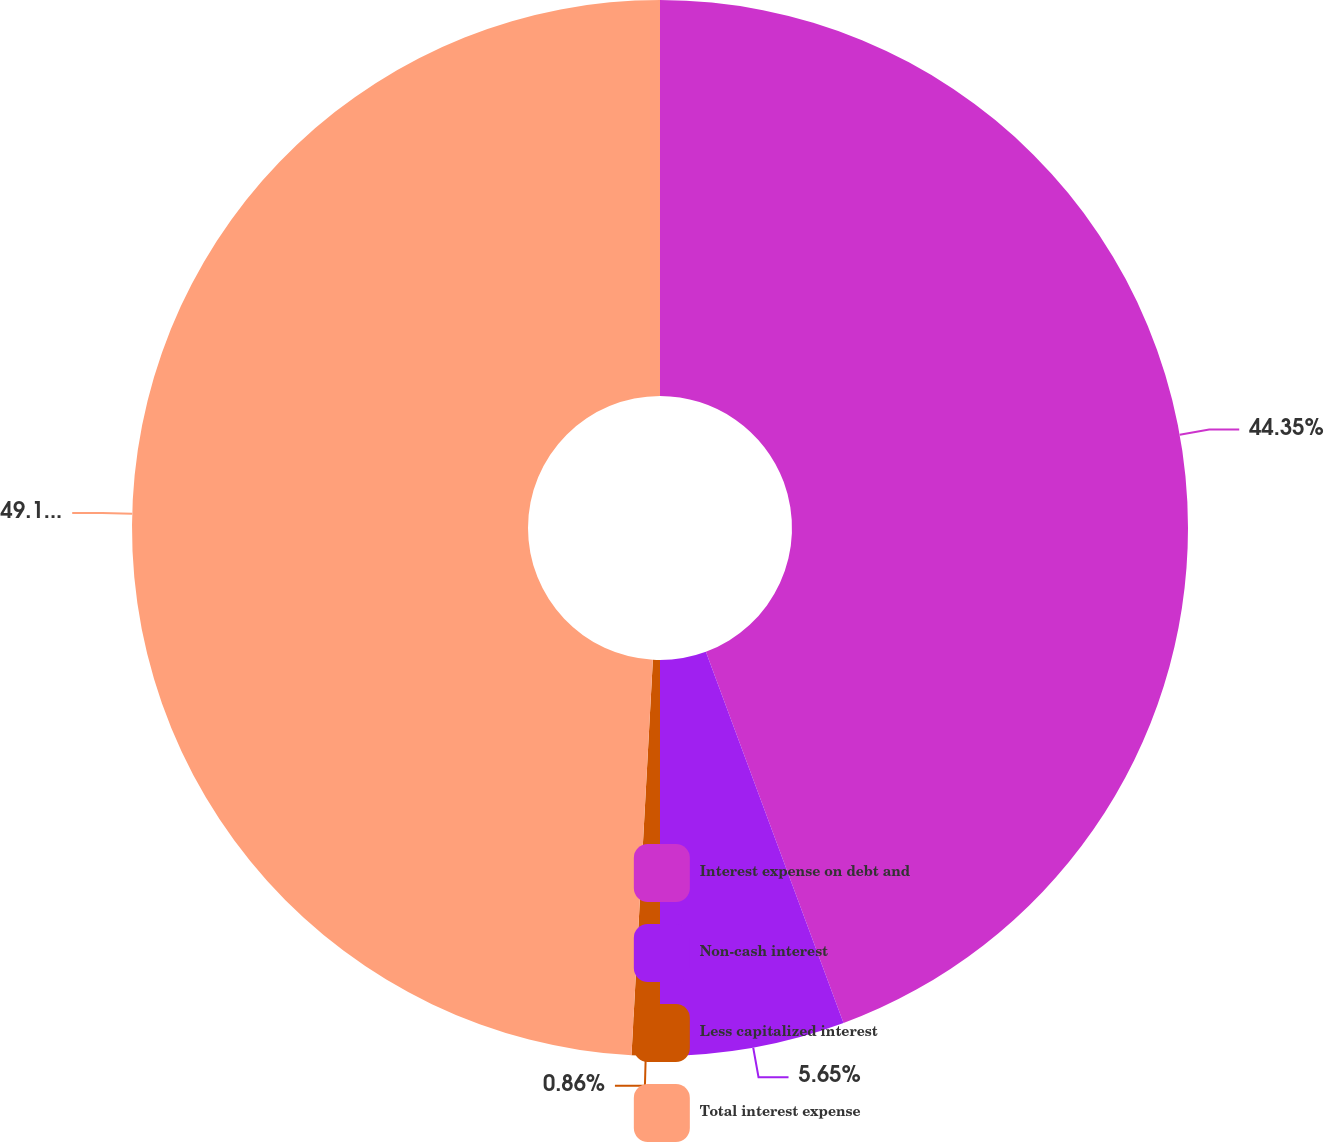<chart> <loc_0><loc_0><loc_500><loc_500><pie_chart><fcel>Interest expense on debt and<fcel>Non-cash interest<fcel>Less capitalized interest<fcel>Total interest expense<nl><fcel>44.35%<fcel>5.65%<fcel>0.86%<fcel>49.14%<nl></chart> 